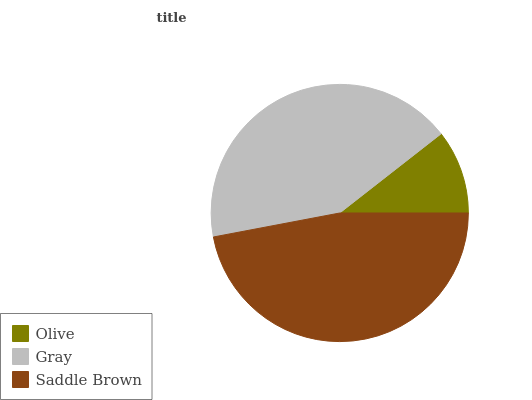Is Olive the minimum?
Answer yes or no. Yes. Is Saddle Brown the maximum?
Answer yes or no. Yes. Is Gray the minimum?
Answer yes or no. No. Is Gray the maximum?
Answer yes or no. No. Is Gray greater than Olive?
Answer yes or no. Yes. Is Olive less than Gray?
Answer yes or no. Yes. Is Olive greater than Gray?
Answer yes or no. No. Is Gray less than Olive?
Answer yes or no. No. Is Gray the high median?
Answer yes or no. Yes. Is Gray the low median?
Answer yes or no. Yes. Is Saddle Brown the high median?
Answer yes or no. No. Is Saddle Brown the low median?
Answer yes or no. No. 